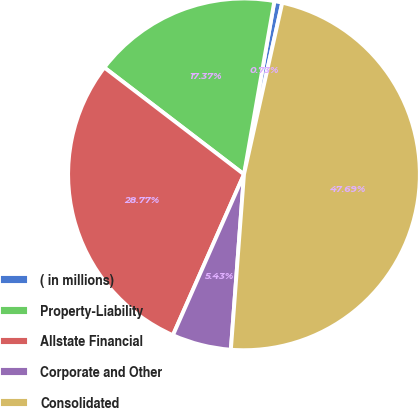Convert chart. <chart><loc_0><loc_0><loc_500><loc_500><pie_chart><fcel>( in millions)<fcel>Property-Liability<fcel>Allstate Financial<fcel>Corporate and Other<fcel>Consolidated<nl><fcel>0.73%<fcel>17.37%<fcel>28.77%<fcel>5.43%<fcel>47.69%<nl></chart> 